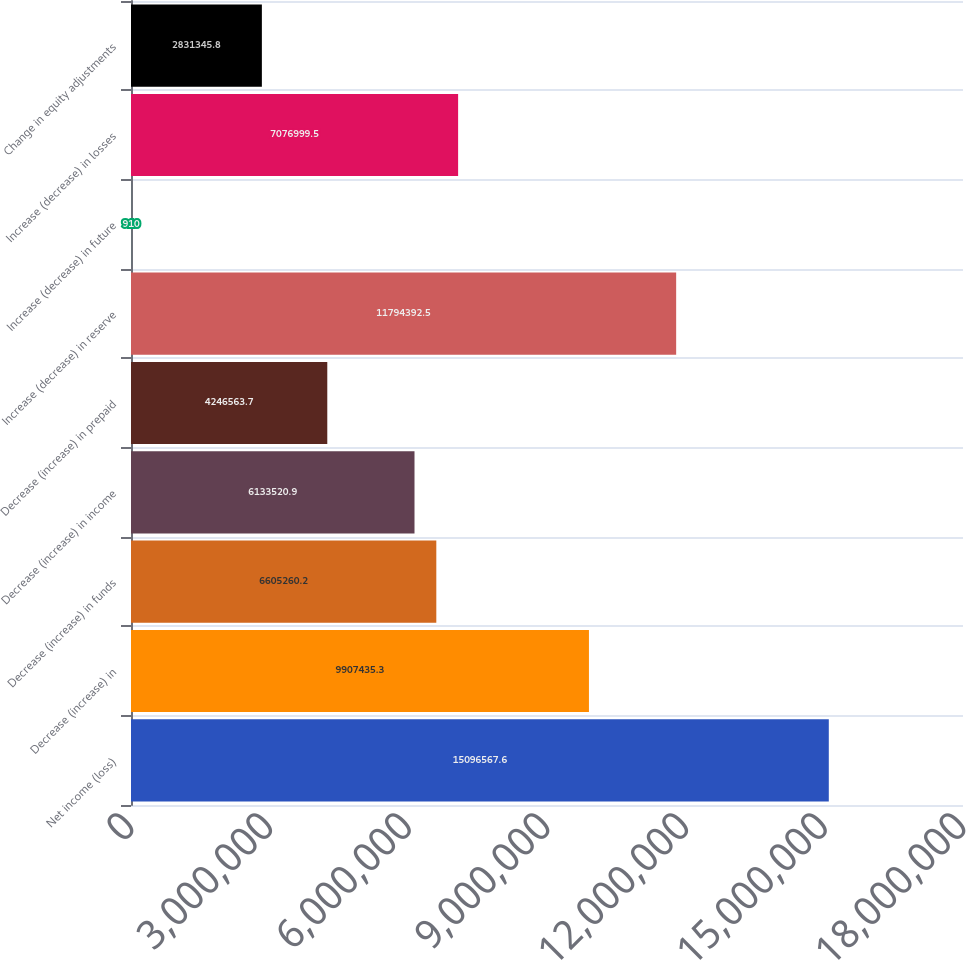Convert chart. <chart><loc_0><loc_0><loc_500><loc_500><bar_chart><fcel>Net income (loss)<fcel>Decrease (increase) in<fcel>Decrease (increase) in funds<fcel>Decrease (increase) in income<fcel>Decrease (increase) in prepaid<fcel>Increase (decrease) in reserve<fcel>Increase (decrease) in future<fcel>Increase (decrease) in losses<fcel>Change in equity adjustments<nl><fcel>1.50966e+07<fcel>9.90744e+06<fcel>6.60526e+06<fcel>6.13352e+06<fcel>4.24656e+06<fcel>1.17944e+07<fcel>910<fcel>7.077e+06<fcel>2.83135e+06<nl></chart> 